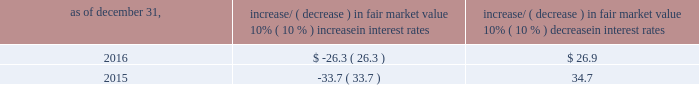Item 7a .
Quantitative and qualitative disclosures about market risk ( amounts in millions ) in the normal course of business , we are exposed to market risks related to interest rates , foreign currency rates and certain balance sheet items .
From time to time , we use derivative instruments , pursuant to established guidelines and policies , to manage some portion of these risks .
Derivative instruments utilized in our hedging activities are viewed as risk management tools and are not used for trading or speculative purposes .
Interest rates our exposure to market risk for changes in interest rates relates primarily to the fair market value and cash flows of our debt obligations .
The majority of our debt ( approximately 93% ( 93 % ) and 89% ( 89 % ) as of december 31 , 2016 and 2015 , respectively ) bears interest at fixed rates .
We do have debt with variable interest rates , but a 10% ( 10 % ) increase or decrease in interest rates would not be material to our interest expense or cash flows .
The fair market value of our debt is sensitive to changes in interest rates , and the impact of a 10% ( 10 % ) change in interest rates is summarized below .
Increase/ ( decrease ) in fair market value as of december 31 , 10% ( 10 % ) increase in interest rates 10% ( 10 % ) decrease in interest rates .
We have used interest rate swaps for risk management purposes to manage our exposure to changes in interest rates .
We do not have any interest rate swaps outstanding as of december 31 , 2016 .
We had $ 1100.6 of cash , cash equivalents and marketable securities as of december 31 , 2016 that we generally invest in conservative , short-term bank deposits or securities .
The interest income generated from these investments is subject to both domestic and foreign interest rate movements .
During 2016 and 2015 , we had interest income of $ 20.1 and $ 22.8 , respectively .
Based on our 2016 results , a 100 basis-point increase or decrease in interest rates would affect our interest income by approximately $ 11.0 , assuming that all cash , cash equivalents and marketable securities are impacted in the same manner and balances remain constant from year-end 2016 levels .
Foreign currency rates we are subject to translation and transaction risks related to changes in foreign currency exchange rates .
Since we report revenues and expenses in u.s .
Dollars , changes in exchange rates may either positively or negatively affect our consolidated revenues and expenses ( as expressed in u.s .
Dollars ) from foreign operations .
The foreign currencies that most impacted our results during 2016 included the british pound sterling and , to a lesser extent , the argentine peso , brazilian real and japanese yen .
Based on 2016 exchange rates and operating results , if the u.s .
Dollar were to strengthen or weaken by 10% ( 10 % ) , we currently estimate operating income would decrease or increase approximately 4% ( 4 % ) , assuming that all currencies are impacted in the same manner and our international revenue and expenses remain constant at 2016 levels .
The functional currency of our foreign operations is generally their respective local currency .
Assets and liabilities are translated at the exchange rates in effect at the balance sheet date , and revenues and expenses are translated at the average exchange rates during the period presented .
The resulting translation adjustments are recorded as a component of accumulated other comprehensive loss , net of tax , in the stockholders 2019 equity section of our consolidated balance sheets .
Our foreign subsidiaries generally collect revenues and pay expenses in their functional currency , mitigating transaction risk .
However , certain subsidiaries may enter into transactions in currencies other than their functional currency .
Assets and liabilities denominated in currencies other than the functional currency are susceptible to movements in foreign currency until final settlement .
Currency transaction gains or losses primarily arising from transactions in currencies other than the functional currency are included in office and general expenses .
We regularly review our foreign exchange exposures that may have a material impact on our business and from time to time use foreign currency forward exchange contracts or other derivative financial instruments to hedge the effects of potential adverse fluctuations in foreign currency exchange rates arising from these exposures .
We do not enter into foreign exchange contracts or other derivatives for speculative purposes. .
What is the percentage change in interest income from 2015 to 2016? 
Computations: ((20.1 - 22.8) / 22.8)
Answer: -0.11842. 